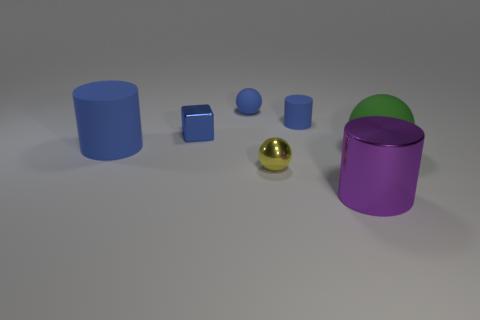Subtract all purple spheres. How many blue cylinders are left? 2 Add 1 red rubber spheres. How many objects exist? 8 Subtract all tiny blue matte balls. How many balls are left? 2 Subtract 1 spheres. How many spheres are left? 2 Subtract all blocks. How many objects are left? 6 Add 2 small gray spheres. How many small gray spheres exist? 2 Subtract 0 green blocks. How many objects are left? 7 Subtract all purple spheres. Subtract all blue cylinders. How many spheres are left? 3 Subtract all purple things. Subtract all tiny metallic cubes. How many objects are left? 5 Add 3 small blue shiny blocks. How many small blue shiny blocks are left? 4 